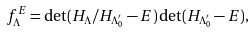<formula> <loc_0><loc_0><loc_500><loc_500>f _ { \Lambda } ^ { E } = \det ( H _ { \Lambda } / H _ { \Lambda _ { 0 } ^ { \prime } } - E ) \det ( H _ { \Lambda _ { 0 } ^ { \prime } } - E ) ,</formula> 